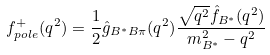<formula> <loc_0><loc_0><loc_500><loc_500>f ^ { + } _ { p o l e } ( q ^ { 2 } ) = \frac { 1 } { 2 } \hat { g } _ { B ^ { * } B \pi } ( q ^ { 2 } ) \frac { \sqrt { q ^ { 2 } } \hat { f } _ { B ^ { * } } ( q ^ { 2 } ) } { m ^ { 2 } _ { B ^ { * } } - q ^ { 2 } }</formula> 